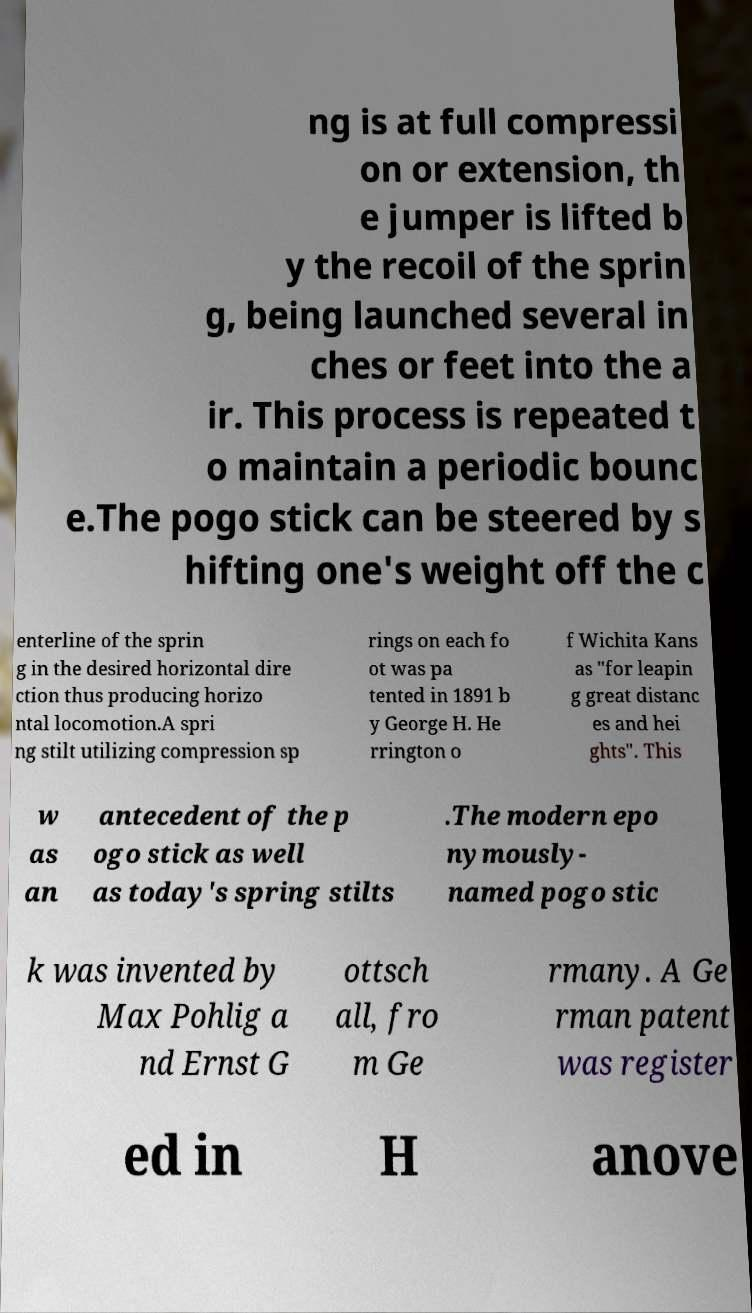Please identify and transcribe the text found in this image. ng is at full compressi on or extension, th e jumper is lifted b y the recoil of the sprin g, being launched several in ches or feet into the a ir. This process is repeated t o maintain a periodic bounc e.The pogo stick can be steered by s hifting one's weight off the c enterline of the sprin g in the desired horizontal dire ction thus producing horizo ntal locomotion.A spri ng stilt utilizing compression sp rings on each fo ot was pa tented in 1891 b y George H. He rrington o f Wichita Kans as "for leapin g great distanc es and hei ghts". This w as an antecedent of the p ogo stick as well as today's spring stilts .The modern epo nymously- named pogo stic k was invented by Max Pohlig a nd Ernst G ottsch all, fro m Ge rmany. A Ge rman patent was register ed in H anove 